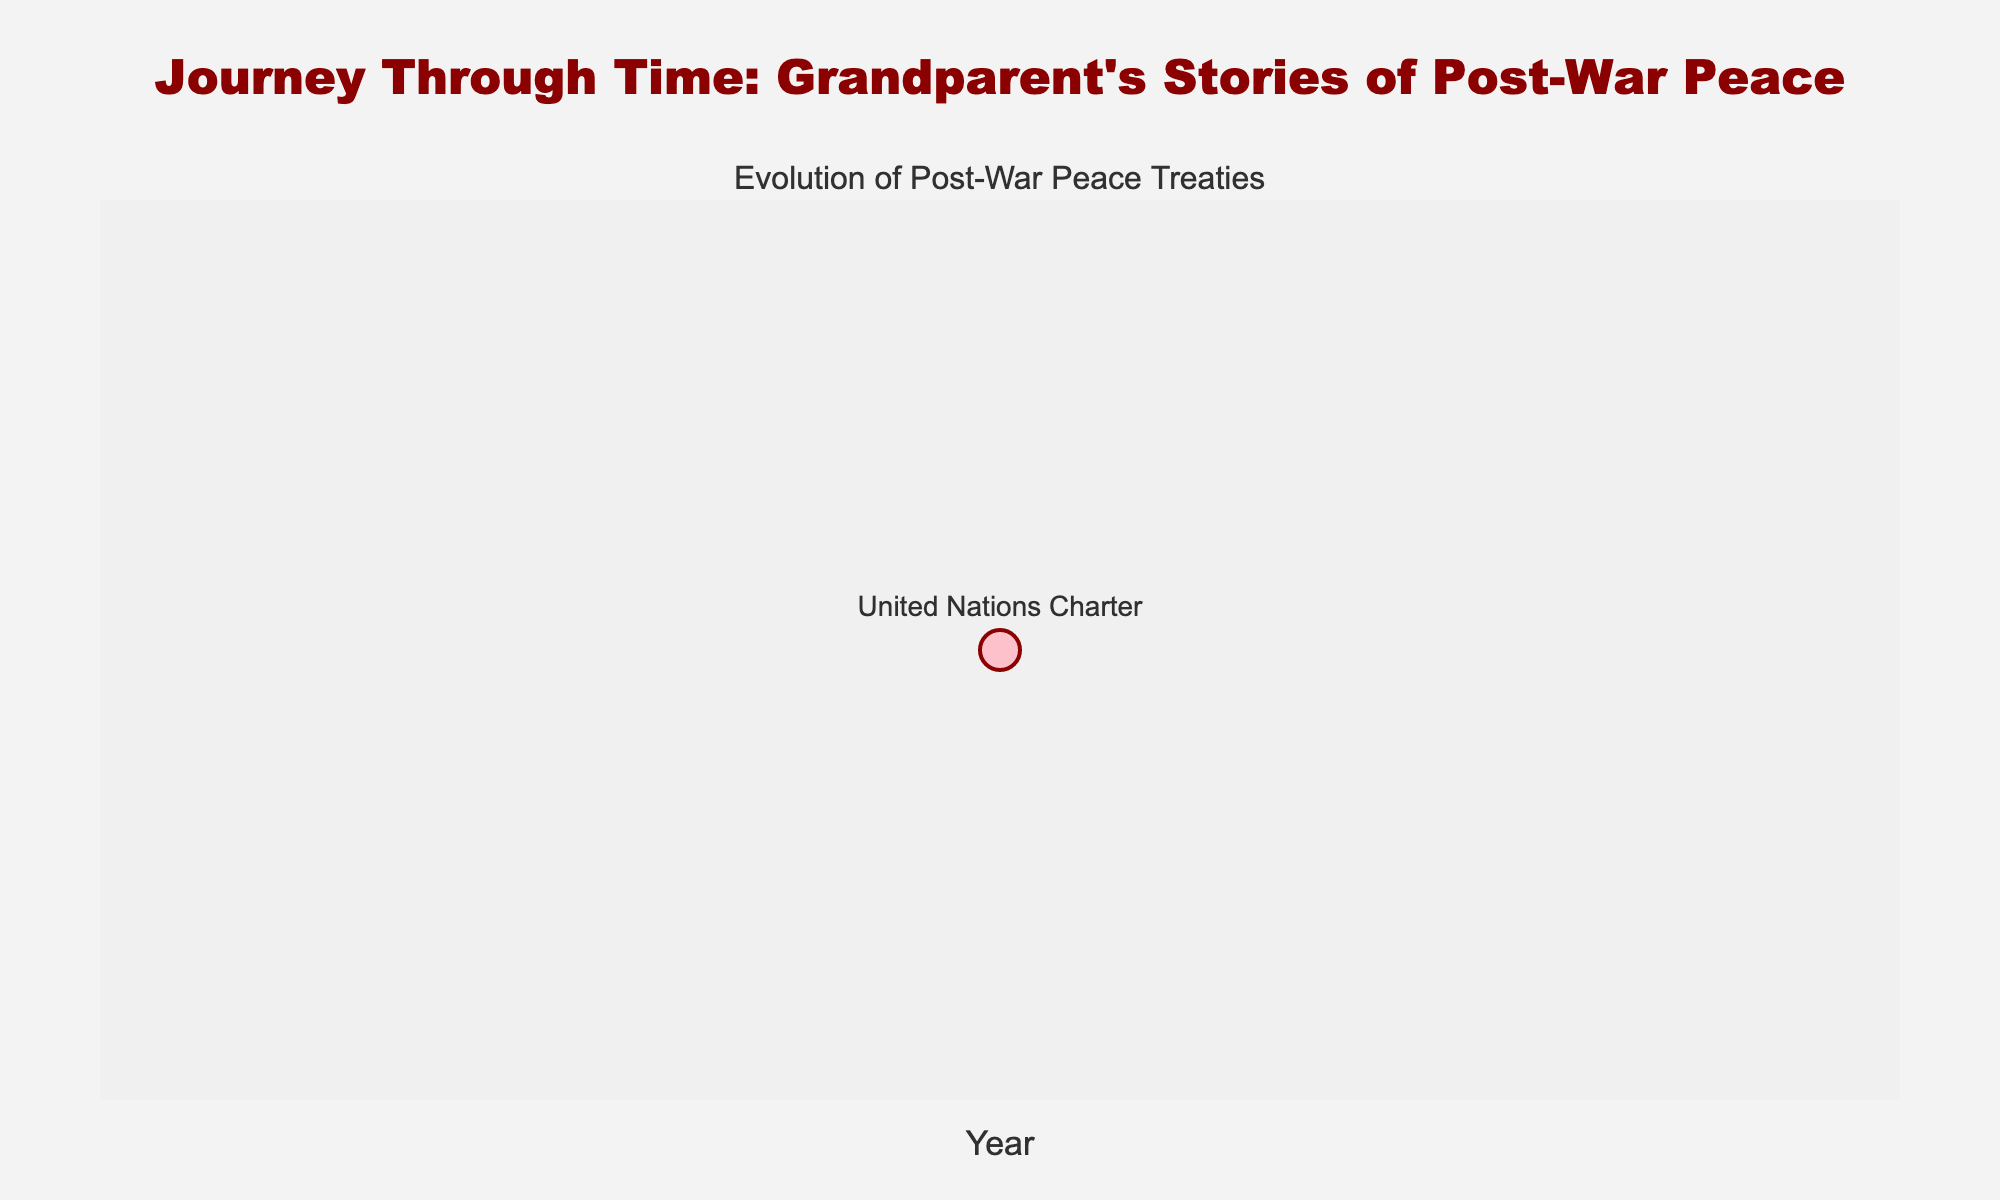What's the title of the figure? The title is usually displayed at the top of the figure in a larger or bolder font than other text elements. In this case, the title can be found at the top center of the figure.
Answer: Journey Through Time: Grandparent's Stories of Post-War Peace How many data points are shown in the figure? Each data point usually corresponds to a specific year in which a peace treaty was established. In this case, there is only one data point represented in the figure.
Answer: 1 What is the color of the markers used in the figure? The markers are often depicted in distinctive colors to make them stand out. Here, the markers are pink with a purple outline, giving them a distinct appearance.
Answer: Pink with a purple outline How many countries were involved in the treaty marked in the figure? By looking at the hover text or a detailed description of the data point in the figure, we can see that the number of countries involved is listed. For the United Nations Charter in 1945, it involved 50 original member countries.
Answer: 50 What is the name of the treaty established in 1945 according to the figure? Typically, the text near the data point or the hover information will show the name of the treaty associated with the year. In this case, the treaty established in 1945 is the United Nations Charter.
Answer: United Nations Charter What is one key feature of the treaty established in 1945? Examining the hover text or associated text with the data point will reveal key features of the treaties. For the United Nations Charter, one key feature is "Established the United Nations."
Answer: Established the United Nations How does the figure indicate the year of the treaty? The figure likely uses the x-axis to indicate different years, with each data point plotted according to the respective year. Here, "Year" is indicated on the x-axis.
Answer: X-axis What was the main conflict associated with the treaty established in 1945? The hover text or detailed description associated with the data point often provides context about the conflict that led to the treaty. For the United Nations Charter in 1945, the main conflict was World War II.
Answer: World War II What is the background color of the figure? The background color sets the visual context for the figure, which often helps in differentiating the data points. In this case, the background color of the plot area is a light gray, which is consistent with "rgba(240, 240, 240, 0.8)".
Answer: Light gray 